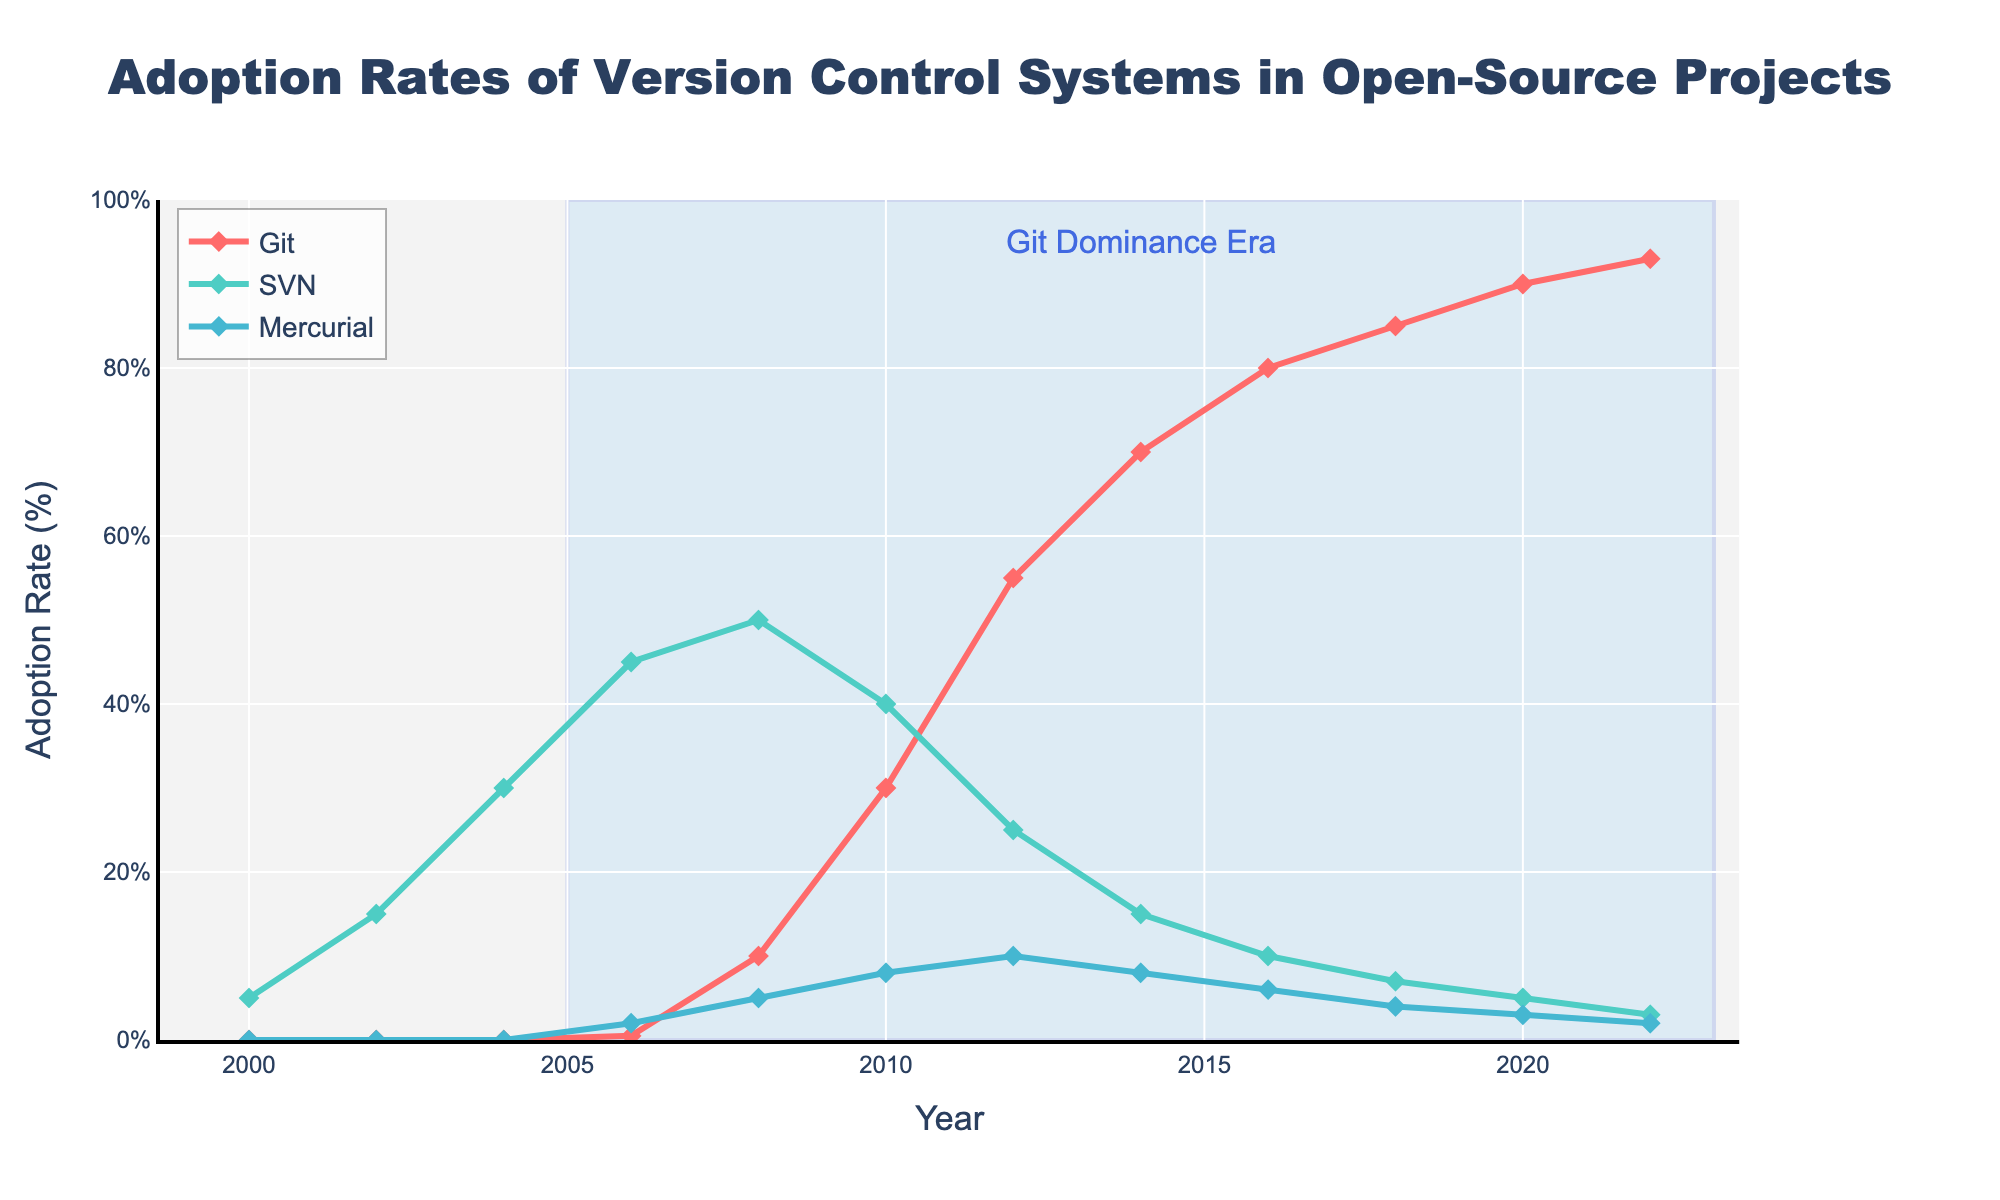What version control system (VCS) had the highest adoption rate in 2008? Look at the adoption rates in 2008 on the figure: Git (10%), SVN (50%), and Mercurial (5%) and compare them directly. SVN had the highest adoption rate.
Answer: SVN How did the adoption rate of SVN change between 2006 and 2010? Check the data points for SVN in 2006 and 2010, which show 45% and 40%, respectively. Calculate the difference: 45% - 40% = 5%. So, the adoption rate of SVN decreased by 5% during this period.
Answer: Decreased by 5% Which VCS showed the largest growth between 2010 and 2012? Compare the adoption rates of each VCS in 2010 and 2012: Git (30% to 55%), SVN (40% to 25%), Mercurial (8% to 10%). Calculate growth: Git increased by 25%, SVN decreased by 15%, and Mercurial increased by 2%. Git had the largest growth.
Answer: Git What visual elements emphasize the "Git Dominance Era"? The plot includes a rectangle shape with a blue fill spanning from 2005 to 2023 to highlight the Git Dominance Era. There is also an annotation at 2014 stating "Git Dominance Era". These visual elements emphasize the era.
Answer: Rectangle and annotation What is the average adoption rate of Mercurial from 2008 to 2012? Identify the values for Mercurial in the years 2008, 2010, 2012: 5%, 8%, 10%. Sum these values: 5 + 8 + 10 = 23. Calculate the average: 23 / 3 ≈ 7.67%.
Answer: 7.67% Which VCS had the most dramatic decline in adoption rate, and over what period did it occur? By reviewing the trends, SVN had the most significant drop between 2008 (50%) and 2012 (25%). Calculate the decline: 50% - 25% = 25%.
Answer: SVN from 2008 to 2012 What trend do you observe for SVN between 2008 and 2022? Notice that SVN's adoption rate consistently declines each year from 50% in 2008 to 3% in 2022. Identify this long-term decreasing trend.
Answer: Consistent decline In what year did Git surpass SVN in adoption rate? Look for the year where Git's adoption rate becomes higher than SVN's. In 2010, Git's adoption rate (30%) is first greater than SVN's (40%). This trend progresses until Git clearly surpasses SVN over the following years.
Answer: 2010 